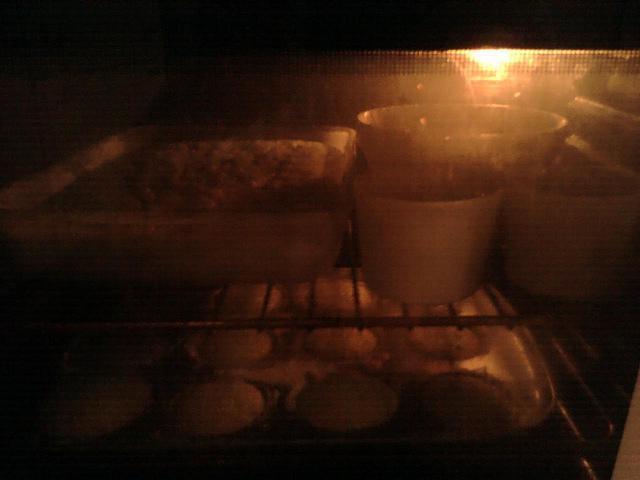Evaluate: Does the caption "The cake is enclosed by the oven." match the image?
Answer yes or no. Yes. Does the image validate the caption "The oven is beneath the cake."?
Answer yes or no. No. 